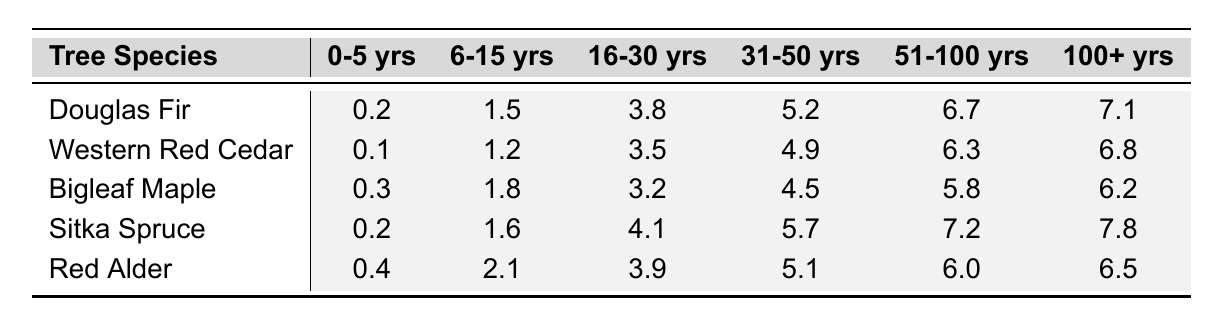What is the carbon sequestration rate of Western Red Cedar at 31-50 years? From the table, we can see that the carbon sequestration rate for Western Red Cedar in the 31-50 years age group is listed as 4.9.
Answer: 4.9 Which tree species has the highest carbon sequestration rate at 100+ years? Referring to the last column for the 100+ years age group, Sitka Spruce shows the highest sequestration rate at 7.8.
Answer: Sitka Spruce What is the average carbon sequestration rate for Bigleaf Maple across all age groups? The rates for Bigleaf Maple are: 0.3, 1.8, 3.2, 4.5, 5.8, and 6.2. Summing these gives 0.3 + 1.8 + 3.2 + 4.5 + 5.8 + 6.2 = 21.8. There are 6 age groups, so the average is 21.8 / 6 = 3.63.
Answer: 3.63 Is the carbon sequestration rate of Red Alder greater than 6 in any age group? Looking at the rates for Red Alder: 0.4, 2.1, 3.9, 5.1, 6.0, and 6.5. The maximum value is 6.5, which is greater than 6, so the answer is yes.
Answer: Yes Which tree species shows the greatest increase in carbon sequestration rate from the 6-15 years to 31-50 years age group? Calculating the difference for each species: 
- Douglas Fir: 5.2 - 1.5 = 3.7 
- Western Red Cedar: 4.9 - 1.2 = 3.7 
- Bigleaf Maple: 4.5 - 1.8 = 2.7 
- Sitka Spruce: 5.7 - 1.6 = 4.1 
- Red Alder: 5.1 - 2.1 = 3.0 
The largest increase is for Sitka Spruce at 4.1.
Answer: Sitka Spruce What is the difference in carbon sequestration rate between Douglas Fir and Bigleaf Maple at 16-30 years? For Douglas Fir, the rate is 3.8, and for Bigleaf Maple, it is 3.2. The difference is 3.8 - 3.2 = 0.6.
Answer: 0.6 